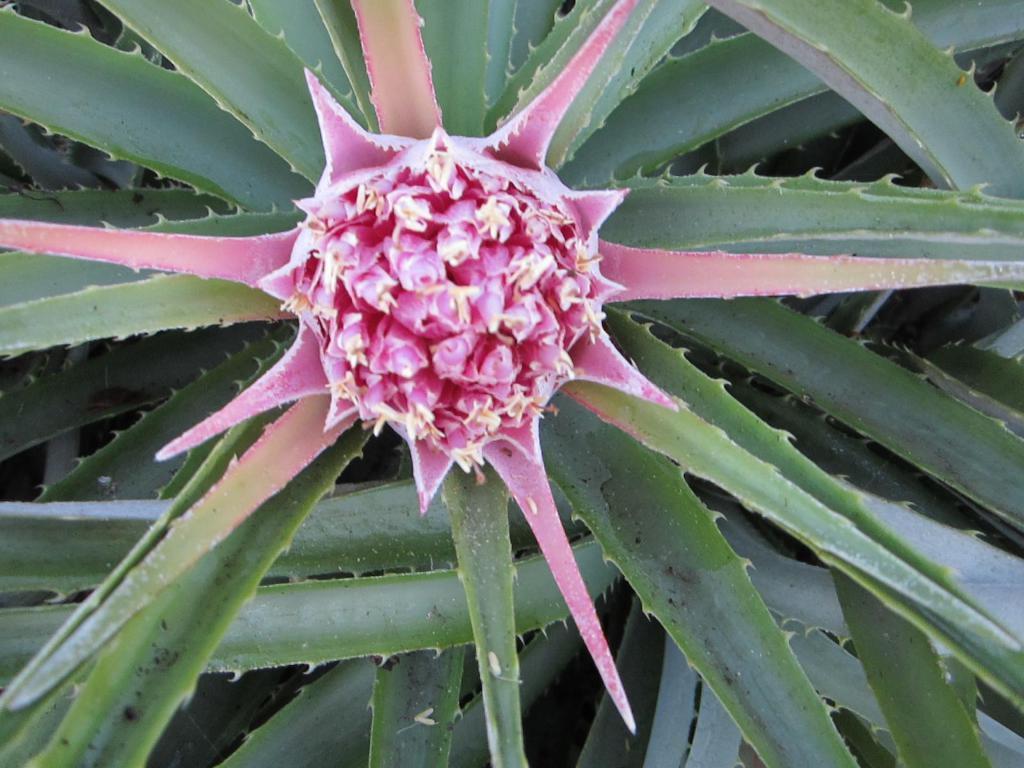Please provide a concise description of this image. In this image I can see the flower to the plant. The flower is in cream and pink color and the plant is in green color. 